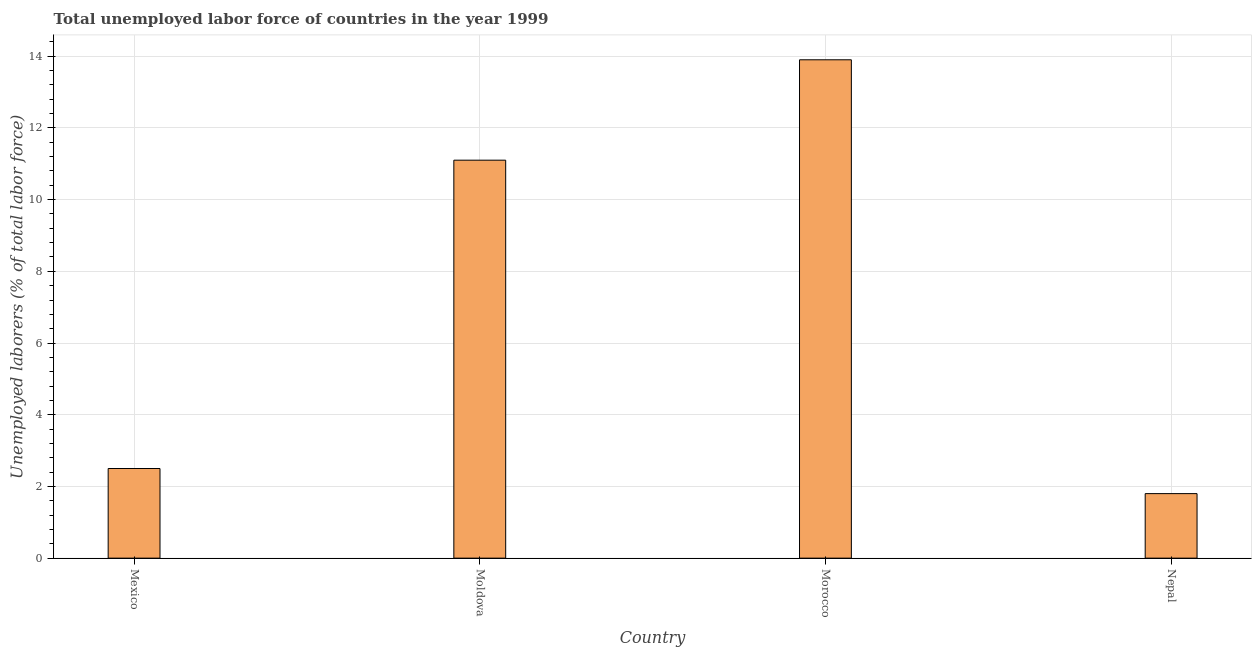Does the graph contain grids?
Keep it short and to the point. Yes. What is the title of the graph?
Keep it short and to the point. Total unemployed labor force of countries in the year 1999. What is the label or title of the Y-axis?
Provide a succinct answer. Unemployed laborers (% of total labor force). What is the total unemployed labour force in Moldova?
Offer a very short reply. 11.1. Across all countries, what is the maximum total unemployed labour force?
Keep it short and to the point. 13.9. Across all countries, what is the minimum total unemployed labour force?
Give a very brief answer. 1.8. In which country was the total unemployed labour force maximum?
Offer a very short reply. Morocco. In which country was the total unemployed labour force minimum?
Ensure brevity in your answer.  Nepal. What is the sum of the total unemployed labour force?
Your answer should be compact. 29.3. What is the difference between the total unemployed labour force in Mexico and Moldova?
Your response must be concise. -8.6. What is the average total unemployed labour force per country?
Provide a succinct answer. 7.33. What is the median total unemployed labour force?
Your answer should be compact. 6.8. In how many countries, is the total unemployed labour force greater than 6.4 %?
Make the answer very short. 2. What is the ratio of the total unemployed labour force in Moldova to that in Morocco?
Offer a terse response. 0.8. Is the total unemployed labour force in Morocco less than that in Nepal?
Ensure brevity in your answer.  No. Is the sum of the total unemployed labour force in Moldova and Morocco greater than the maximum total unemployed labour force across all countries?
Offer a terse response. Yes. What is the difference between the highest and the lowest total unemployed labour force?
Offer a very short reply. 12.1. In how many countries, is the total unemployed labour force greater than the average total unemployed labour force taken over all countries?
Ensure brevity in your answer.  2. How many bars are there?
Your answer should be compact. 4. What is the difference between two consecutive major ticks on the Y-axis?
Offer a terse response. 2. Are the values on the major ticks of Y-axis written in scientific E-notation?
Provide a succinct answer. No. What is the Unemployed laborers (% of total labor force) in Moldova?
Your answer should be very brief. 11.1. What is the Unemployed laborers (% of total labor force) in Morocco?
Your response must be concise. 13.9. What is the Unemployed laborers (% of total labor force) in Nepal?
Your answer should be compact. 1.8. What is the difference between the Unemployed laborers (% of total labor force) in Mexico and Nepal?
Keep it short and to the point. 0.7. What is the difference between the Unemployed laborers (% of total labor force) in Moldova and Nepal?
Your answer should be compact. 9.3. What is the difference between the Unemployed laborers (% of total labor force) in Morocco and Nepal?
Your answer should be very brief. 12.1. What is the ratio of the Unemployed laborers (% of total labor force) in Mexico to that in Moldova?
Your answer should be compact. 0.23. What is the ratio of the Unemployed laborers (% of total labor force) in Mexico to that in Morocco?
Give a very brief answer. 0.18. What is the ratio of the Unemployed laborers (% of total labor force) in Mexico to that in Nepal?
Your response must be concise. 1.39. What is the ratio of the Unemployed laborers (% of total labor force) in Moldova to that in Morocco?
Make the answer very short. 0.8. What is the ratio of the Unemployed laborers (% of total labor force) in Moldova to that in Nepal?
Your answer should be very brief. 6.17. What is the ratio of the Unemployed laborers (% of total labor force) in Morocco to that in Nepal?
Provide a succinct answer. 7.72. 